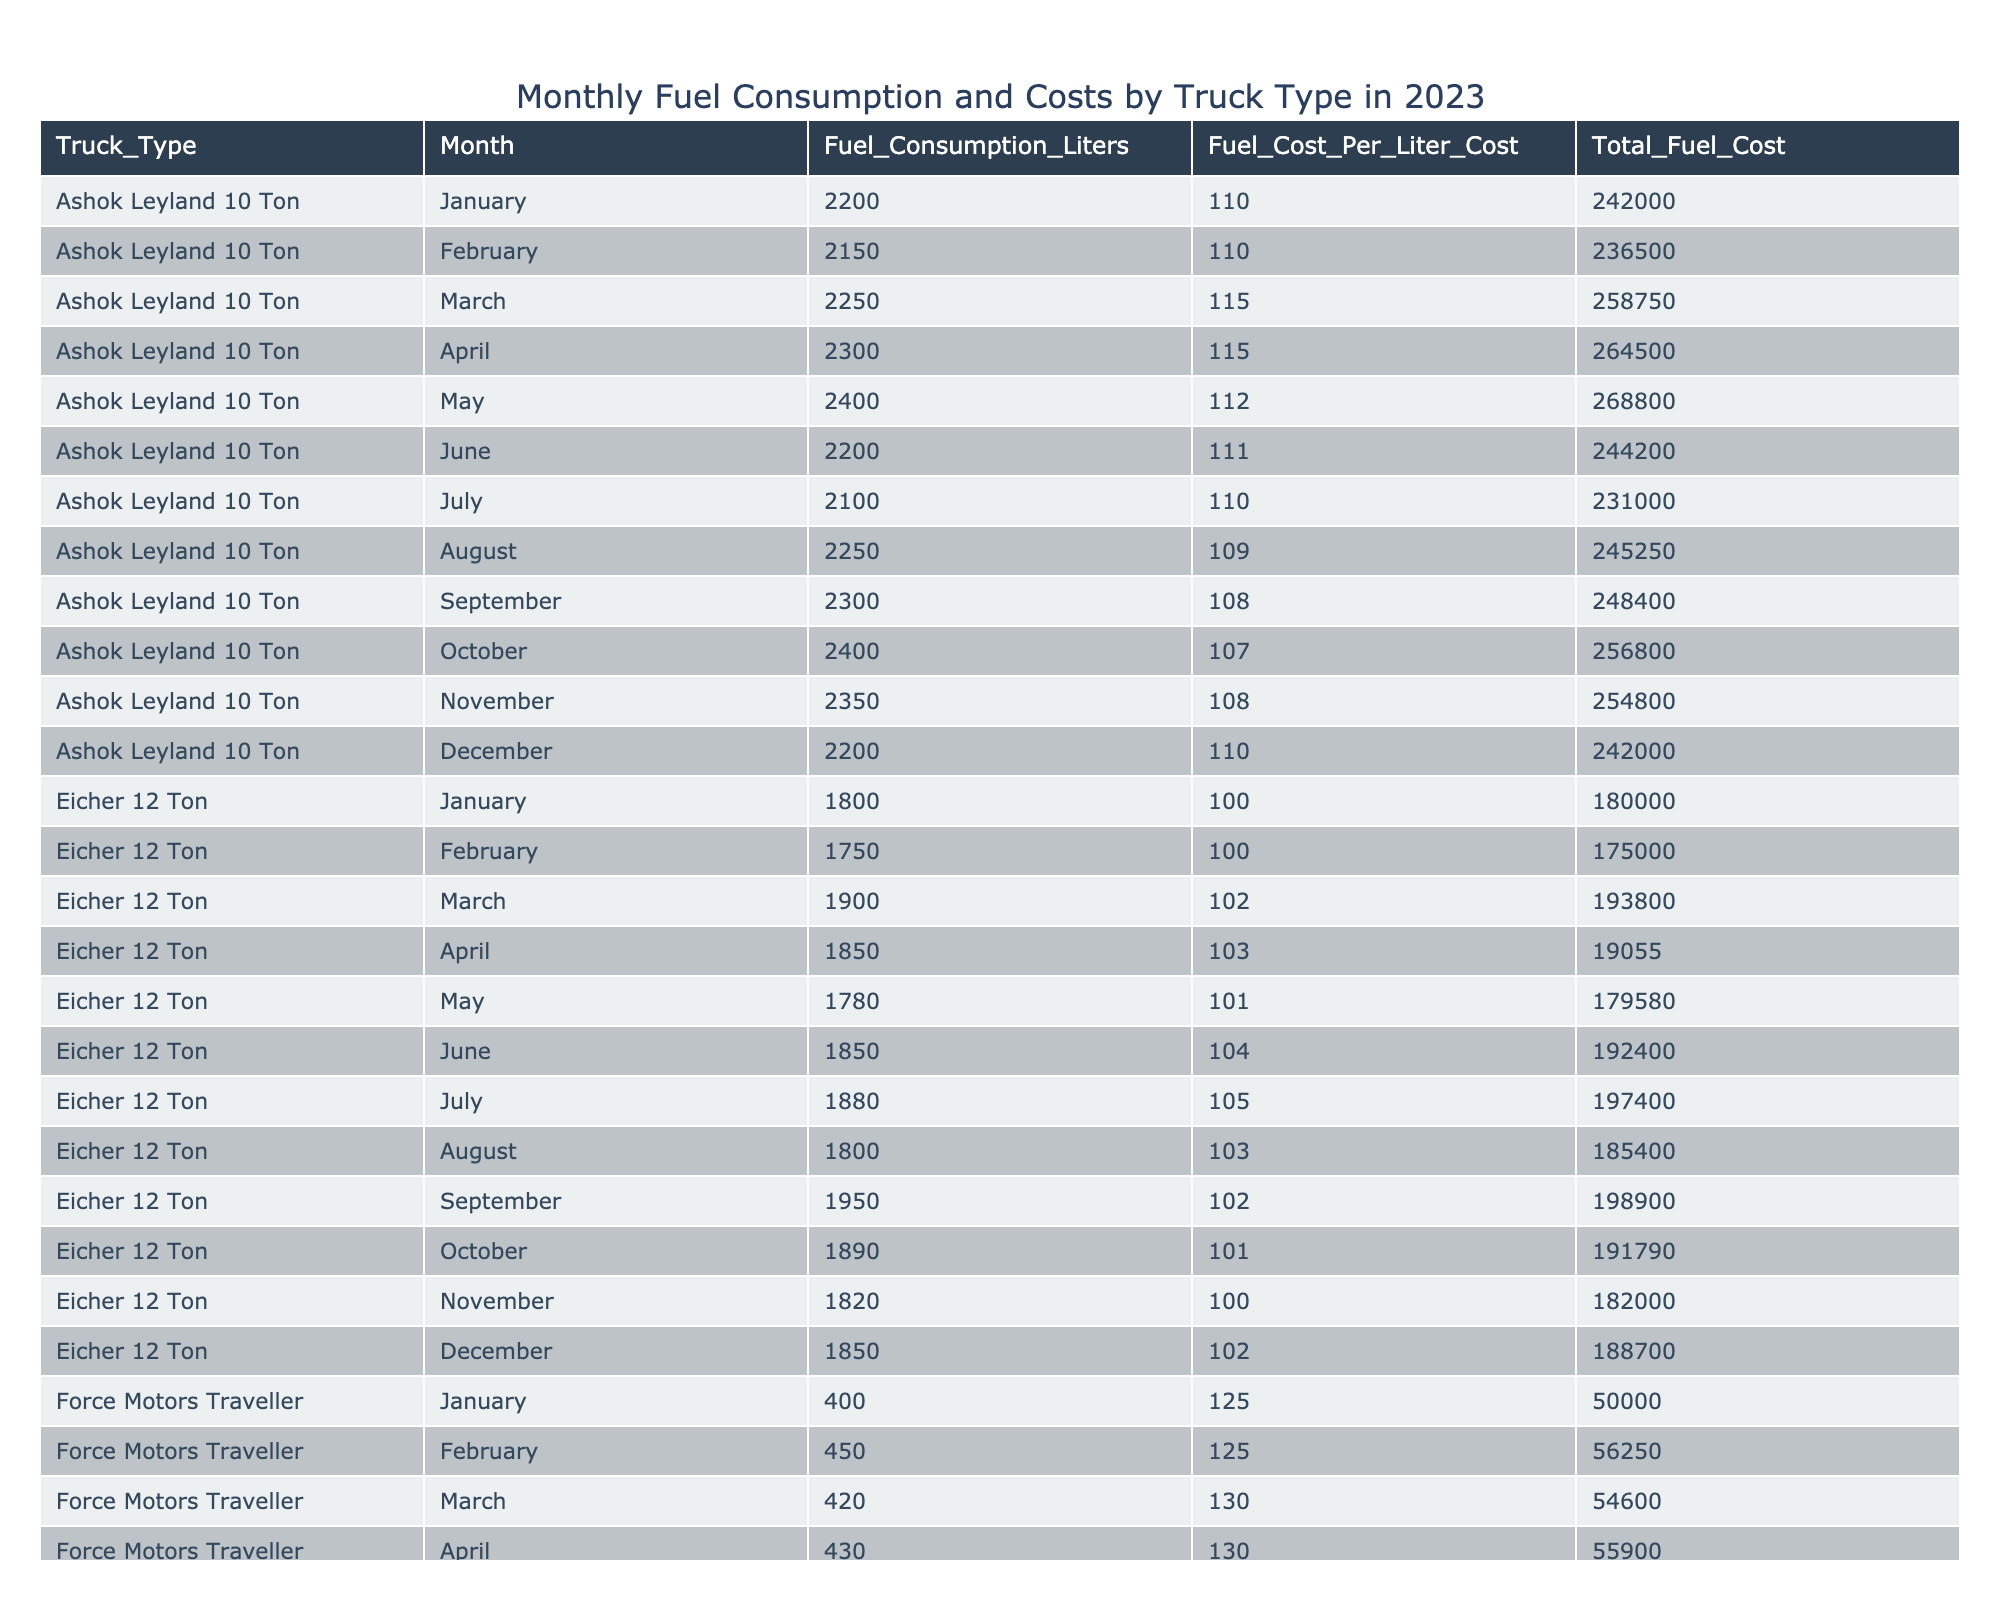What is the total fuel cost for Tata 407 in December? The table lists the total fuel cost for Tata 407 in December as 187,000.
Answer: 187000 Which truck type consumed the most fuel in November? Looking at the data for November, the Eicher 12 Ton consumed the most fuel, with a consumption of 1,820 liters.
Answer: Eicher 12 Ton What is the average fuel cost per liter for Ashok Leyland 10 Ton across the months? Adding up the fuel costs per liter (110 + 110 + 115 + 115 + 112 + 111 + 110 + 109 + 108 + 107 + 108 + 110 = 1329) and dividing by the number of months (12), the average is 1329/12 = 110.75.
Answer: 110.75 Did Mahindra Bolero have a total fuel cost of more than 10,000 in any month? Checking the total fuel costs for Mahindra Bolero in each month, all values are below 10,000, so the statement is false.
Answer: No What was the highest total fuel cost for any truck type in October? The total fuel costs for October were Tata 407 (157,940), Ashok Leyland 10 Ton (256,800), Eicher 12 Ton (191,790), Mahindra Bolero (64,900), and Force Motors Traveller (57,200). The highest cost was Ashok Leyland 10 Ton at 256,800.
Answer: 256800 What is the total fuel consumption of Tata 407 for the first half of the year? The total consumption from January to June is (1500 + 1600 + 1550 + 1400 + 1450 + 1600) = 9300 liters.
Answer: 9300 How does the total fuel cost of Force Motors Traveller compare with that of Eicher 12 Ton in February? The total fuel cost for Force Motors Traveller in February is 56,250, while for Eicher 12 Ton, it's 175,000. Therefore, Force Motors Traveller's cost is significantly lower.
Answer: Lower Which truck type had the least total fuel cost in April? The total fuel cost in April for all types are: Tata 407 (154,000), Ashok Leyland 10 Ton (264,500), Eicher 12 Ton (190,550), Mahindra Bolero (71,300), and Force Motors Traveller (55,900). The least is from Force Motors Traveller.
Answer: Force Motors Traveller What is the total fuel cost for all truck types in March combined? Adding the total fuel costs for March: Tata 407 (170,500) + Ashok Leyland 10 Ton (258,750) + Eicher 12 Ton (193,800) + Mahindra Bolero (67,850) + Force Motors Traveller (54,600) = 745,500.
Answer: 745500 What trend can be observed in the fuel costs for Ashok Leyland 10 Ton from January to December? The trend shows fluctuations in fuel costs throughout the year, peaking in April at 264,500 and dropping back down to 242,000 in December. Overall, there appears to be a slight decline over the year.
Answer: Fluctuating with a slight decline 